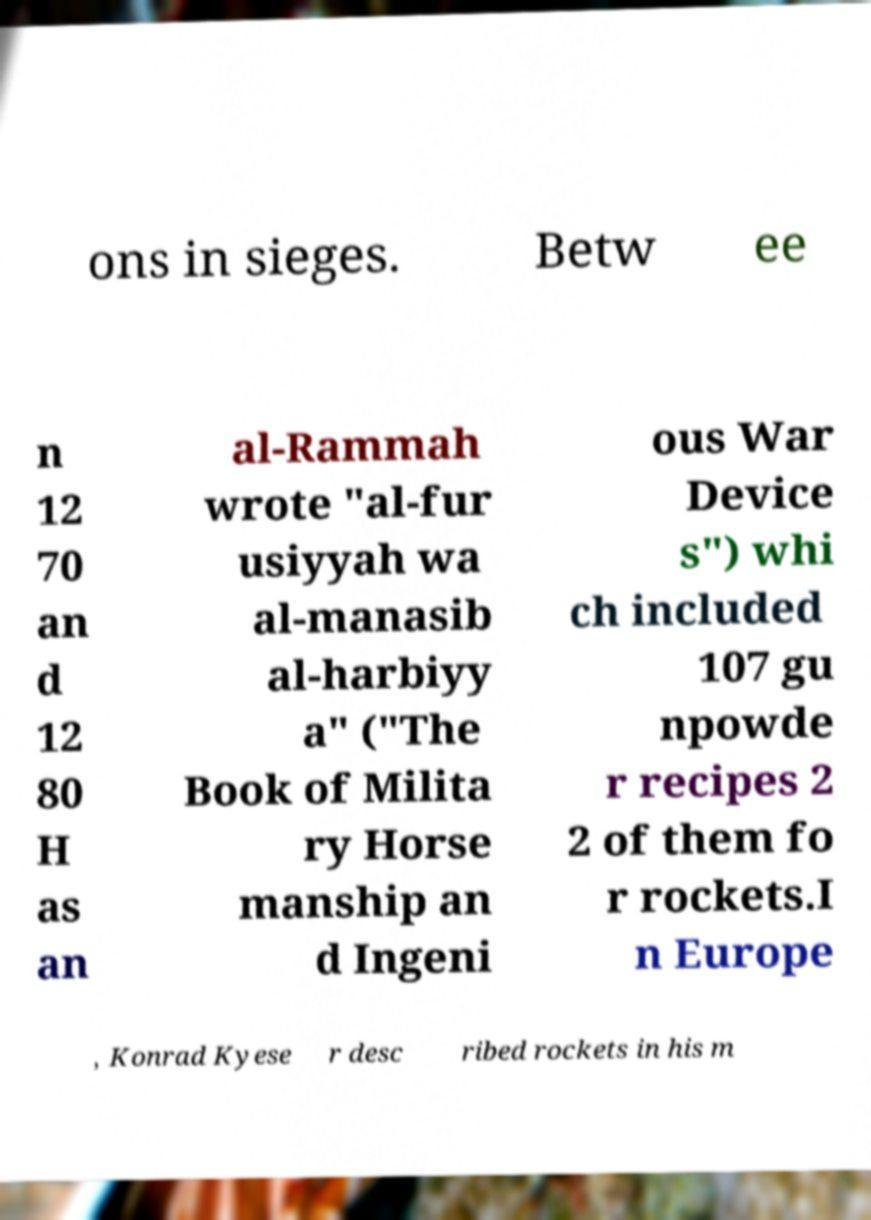I need the written content from this picture converted into text. Can you do that? ons in sieges. Betw ee n 12 70 an d 12 80 H as an al-Rammah wrote "al-fur usiyyah wa al-manasib al-harbiyy a" ("The Book of Milita ry Horse manship an d Ingeni ous War Device s") whi ch included 107 gu npowde r recipes 2 2 of them fo r rockets.I n Europe , Konrad Kyese r desc ribed rockets in his m 